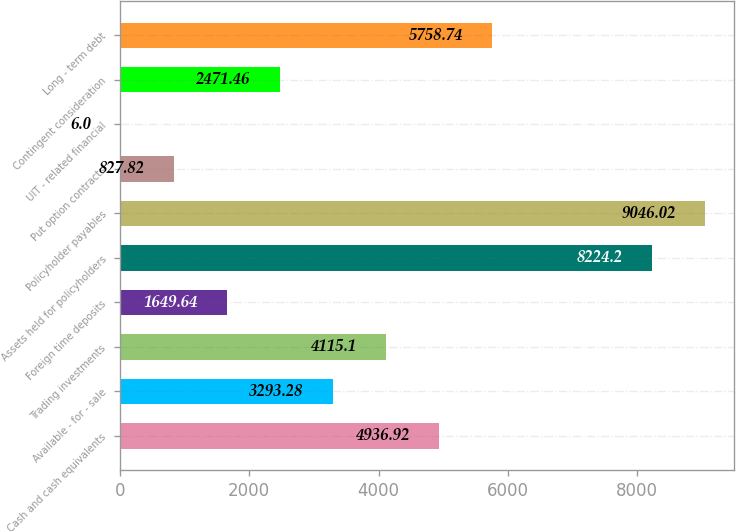Convert chart to OTSL. <chart><loc_0><loc_0><loc_500><loc_500><bar_chart><fcel>Cash and cash equivalents<fcel>Available - for - sale<fcel>Trading investments<fcel>Foreign time deposits<fcel>Assets held for policyholders<fcel>Policyholder payables<fcel>Put option contracts<fcel>UIT - related financial<fcel>Contingent consideration<fcel>Long - term debt<nl><fcel>4936.92<fcel>3293.28<fcel>4115.1<fcel>1649.64<fcel>8224.2<fcel>9046.02<fcel>827.82<fcel>6<fcel>2471.46<fcel>5758.74<nl></chart> 